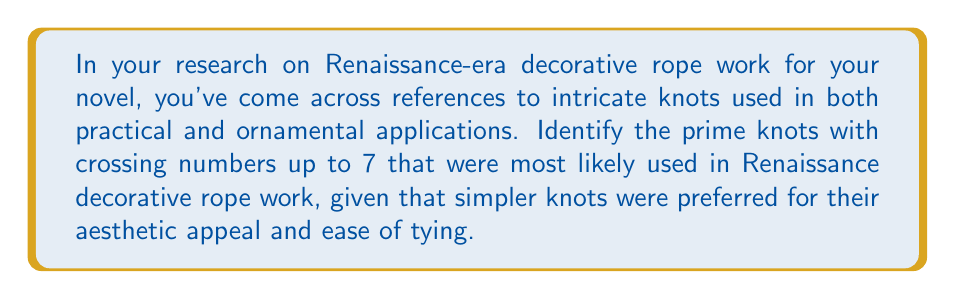Solve this math problem. To answer this question, we need to consider the concept of prime knots and their crossing numbers in the context of Renaissance-era rope work:

1. Prime knots: These are knots that cannot be decomposed into simpler knots. They are the fundamental building blocks of knot theory.

2. Crossing number: This is the minimum number of crossings that occur in any diagram of the knot.

3. Renaissance preference: Simpler knots were favored for their visual appeal and practicality.

Let's examine the prime knots with crossing numbers up to 7:

- Crossing number 3: Trefoil knot ($$3_1$$)
- Crossing number 4: Figure-eight knot ($$4_1$$)
- Crossing number 5: $$5_1$$ and $$5_2$$ knots
- Crossing number 6: $$6_1$$, $$6_2$$, and $$6_3$$ knots
- Crossing number 7: $$7_1$$, $$7_2$$, $$7_3$$, $$7_4$$, $$7_5$$, $$7_6$$, and $$7_7$$ knots

Given the Renaissance preference for simpler knots, we can reasonably conclude that the most likely used prime knots were those with the lowest crossing numbers:

1. Trefoil knot ($$3_1$$): The simplest non-trivial knot, often used in decorative work.
2. Figure-eight knot ($$4_1$$): Another simple knot with aesthetic appeal.
3. $$5_1$$ knot: The simplest knot with 5 crossings, still manageable for decorative purposes.

The knots with 6 or 7 crossings would likely have been too complex for common use in Renaissance decorative rope work, though they might have been used in specialized or highly intricate designs.
Answer: $$3_1$$, $$4_1$$, and $$5_1$$ knots 